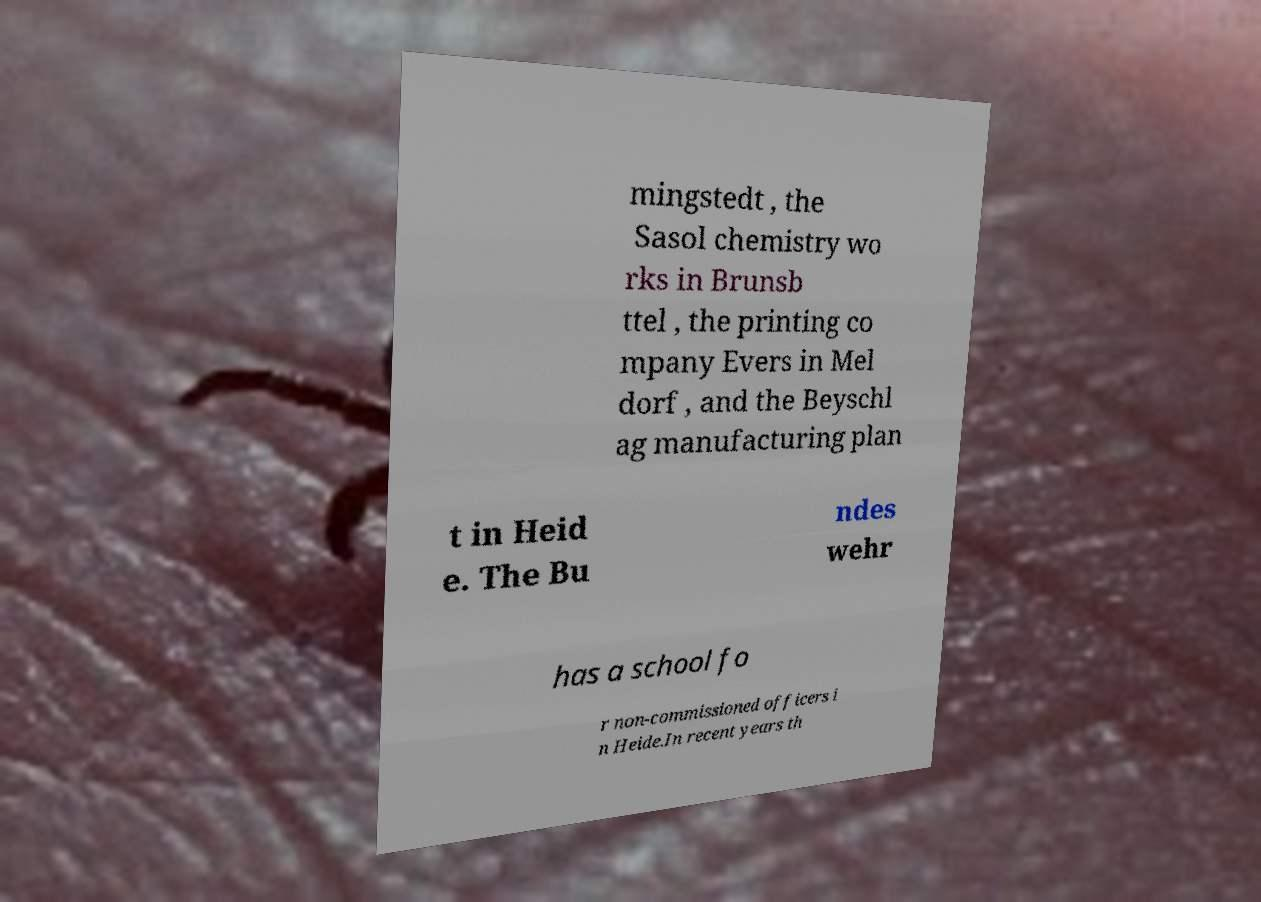Can you accurately transcribe the text from the provided image for me? mingstedt , the Sasol chemistry wo rks in Brunsb ttel , the printing co mpany Evers in Mel dorf , and the Beyschl ag manufacturing plan t in Heid e. The Bu ndes wehr has a school fo r non-commissioned officers i n Heide.In recent years th 